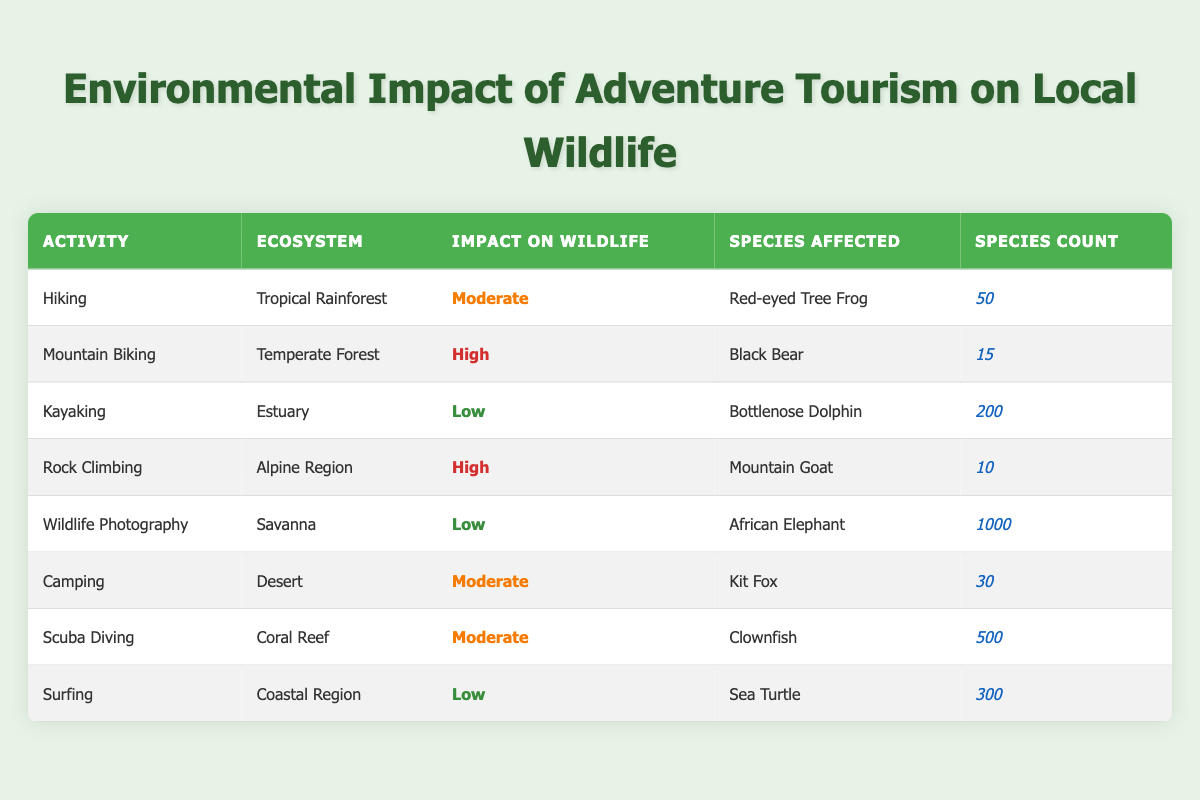What is the impact level of Mountain Biking on wildlife? Mountain Biking has an impact level of "High" as per the table, where it specifically affects the Black Bear with a species count of 15.
Answer: High How many species are affected by Camping? The table shows that Camping affects the Kit Fox, which falls under the category of moderate impact, with a species count of 30.
Answer: Kit Fox What is the total species count impacted by activities with a "Low" impact on wildlife? The activities with low impact are Kayaking (200), Wildlife Photography (1000), and Surfing (300). Adding these gives: 200 + 1000 + 300 = 1500.
Answer: 1500 Which ecosystem has the highest number of species affected? The Savanna shows the highest species count at 1000, affecting the African Elephant, indicating significant wildlife presence there compared to others listed.
Answer: Savanna Is the impact of Rock Climbing higher than that of Hiking? Yes, Rock Climbing has a "High" impact while Hiking has a "Moderate" impact, thus confirming that Rock Climbing affects wildlife more severely.
Answer: Yes How many activities have a "Moderate" impact on wildlife? The table lists three activities (Hiking, Camping, and Scuba Diving) with a moderate impact. Thus, there are three such activities.
Answer: 3 Which activity affects the fewest number of species? Rock Climbing affects the Mountain Goat, with a species count of 10, which is the lowest among all the listed activities in the table.
Answer: Rock Climbing Are there any activities that do not impact local wildlife? No, every listed activity in the table has some level of impact on local wildlife, whether it's low, moderate, or high.
Answer: No What is the average species count for activities that have a "Moderate" impact? The species counts for activities with moderate impact are Hiking (50), Camping (30), and Scuba Diving (500). The average is (50 + 30 + 500) / 3 = 580 / 3 ≈ 193.33.
Answer: 193.33 